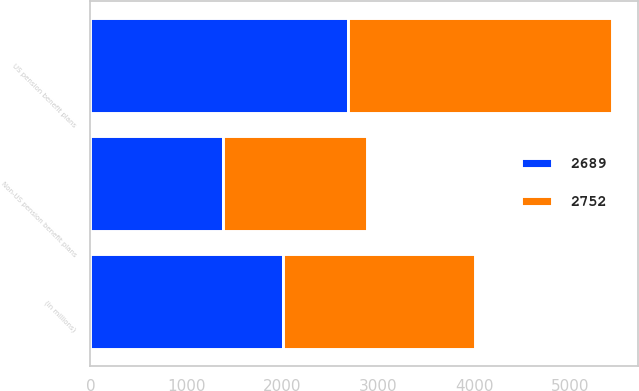Convert chart. <chart><loc_0><loc_0><loc_500><loc_500><stacked_bar_chart><ecel><fcel>(in millions)<fcel>Non-US pension benefit plans<fcel>US pension benefit plans<nl><fcel>2752<fcel>2007<fcel>1504<fcel>2752<nl><fcel>2689<fcel>2006<fcel>1384<fcel>2689<nl></chart> 